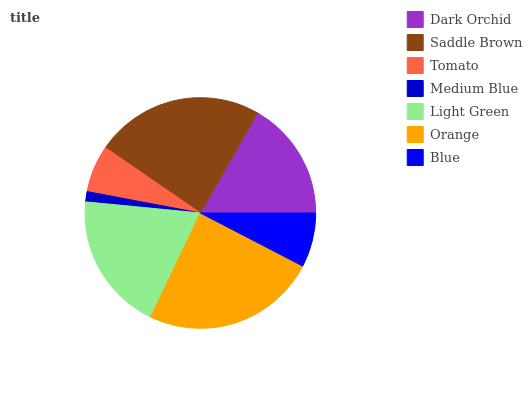Is Medium Blue the minimum?
Answer yes or no. Yes. Is Orange the maximum?
Answer yes or no. Yes. Is Saddle Brown the minimum?
Answer yes or no. No. Is Saddle Brown the maximum?
Answer yes or no. No. Is Saddle Brown greater than Dark Orchid?
Answer yes or no. Yes. Is Dark Orchid less than Saddle Brown?
Answer yes or no. Yes. Is Dark Orchid greater than Saddle Brown?
Answer yes or no. No. Is Saddle Brown less than Dark Orchid?
Answer yes or no. No. Is Dark Orchid the high median?
Answer yes or no. Yes. Is Dark Orchid the low median?
Answer yes or no. Yes. Is Blue the high median?
Answer yes or no. No. Is Blue the low median?
Answer yes or no. No. 